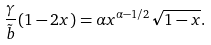<formula> <loc_0><loc_0><loc_500><loc_500>\frac { \gamma } { \tilde { b } } ( 1 - 2 x ) = \alpha x ^ { \alpha - 1 / 2 } \sqrt { 1 - x } .</formula> 